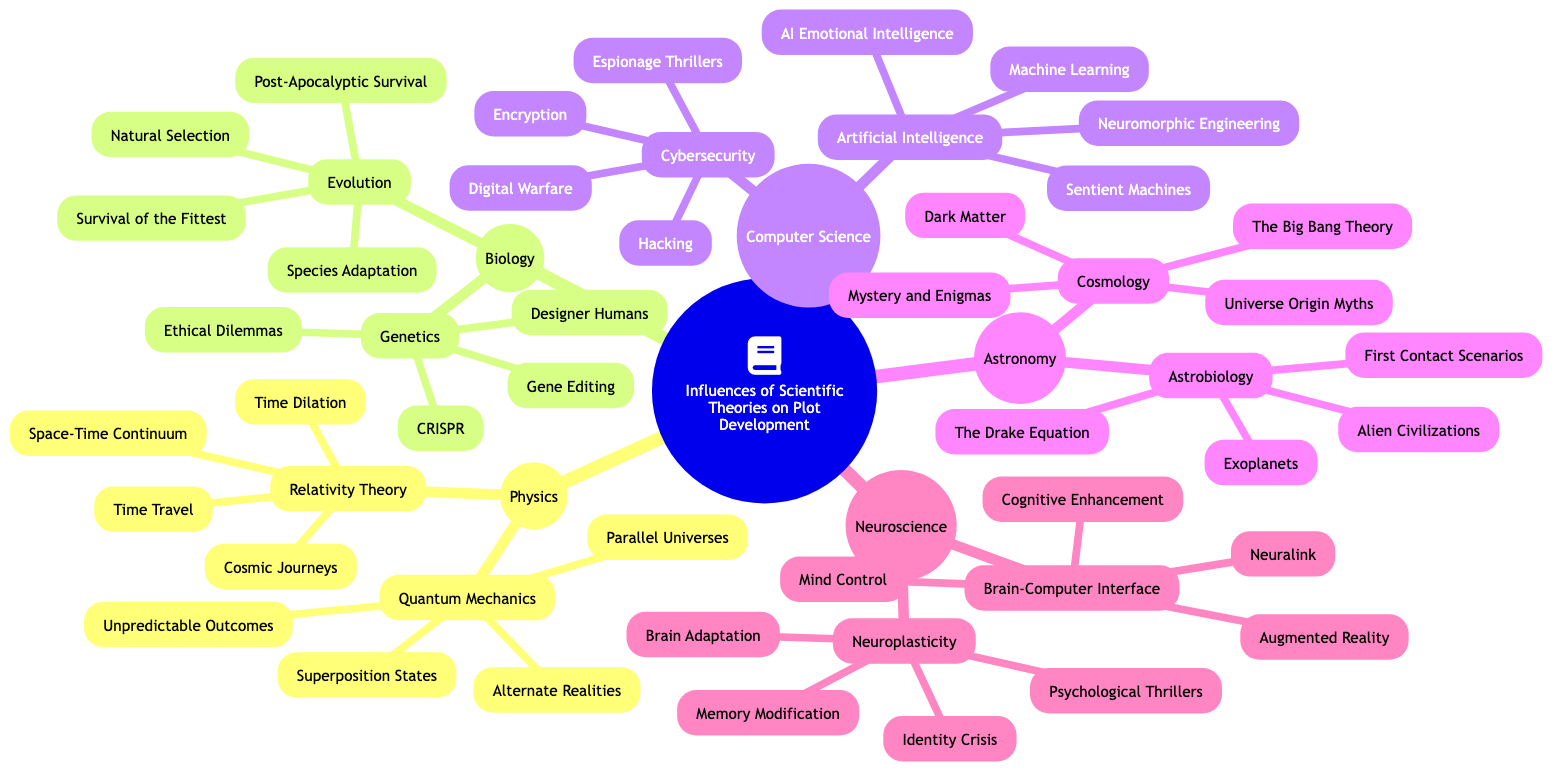What are the two main branches of science in the diagram? The main branches of science in the diagram are "Physics" and "Biology". By examining the top-level nodes, I can identify these two branches that influence plot development.
Answer: Physics, Biology How many concepts are listed under "Quantum Mechanics"? Under the "Quantum Mechanics" branch, there are two concepts listed: "Parallel Universes" and "Superposition States". By counting the individual items in that section, I can identify the total.
Answer: 2 What type of plot impact does "Neuroplasticity" lead to? The impact on plot from "Neuroplasticity" leads to "Psychological Thrillers" and "Identity Crisis". By looking at the outcome section for this concept, I can summarize these two plot impacts.
Answer: Psychological Thrillers, Identity Crisis Which scientific theory includes "Time Dilation"? "Time Dilation" is a concept included in "Relativity Theory". By following the branch for "Relativity Theory," I can confirm this specific concept belongs to that category.
Answer: Relativity Theory What are two plot impacts associated with "Artificial Intelligence"? "Artificial Intelligence" includes two impacts: "Sentient Machines" and "AI Emotional Intelligence". I can find these impacts listed directly under the concept in the diagram.
Answer: Sentient Machines, AI Emotional Intelligence How many scientific fields are represented in the diagram? The diagram represents five scientific fields: Physics, Biology, Computer Science, Astronomy, and Neuroscience. By counting the top-level branches, I can determine the total number of fields included.
Answer: 5 What is the relationship between "Astrobiology" and "First Contact Scenarios"? "First Contact Scenarios" is a plot impact connected to "Astrobiology". The diagram shows that "First Contact Scenarios" results from concepts under "Astrobiology".
Answer: Astrobiology, First Contact Scenarios How does "Gene Editing" impact plot development? "Gene Editing" impacts plot development by leading to "Designer Humans" and "Ethical Dilemmas". These impacts are specifically linked to the "Genetics" branch under Biology.
Answer: Designer Humans, Ethical Dilemmas 